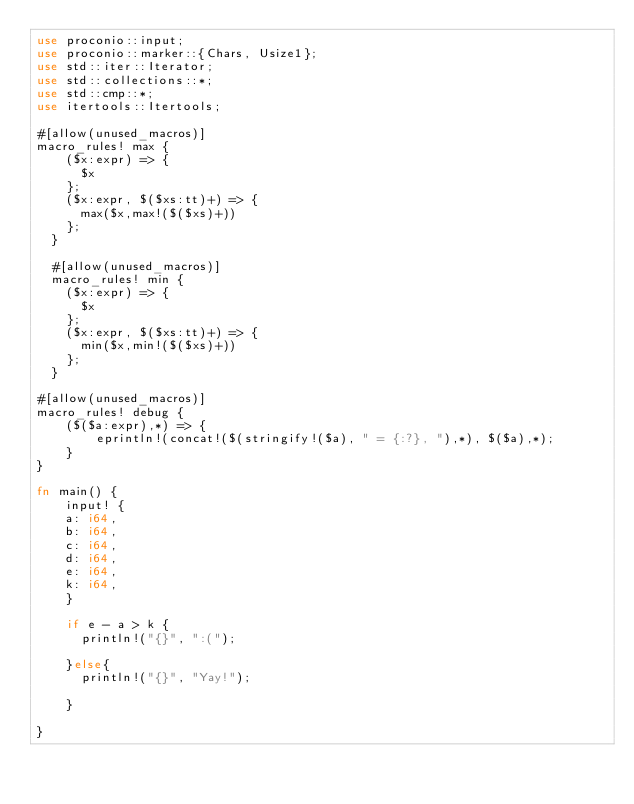<code> <loc_0><loc_0><loc_500><loc_500><_Rust_>use proconio::input;
use proconio::marker::{Chars, Usize1};
use std::iter::Iterator;
use std::collections::*;
use std::cmp::*;
use itertools::Itertools;

#[allow(unused_macros)]
macro_rules! max {
    ($x:expr) => {
      $x
    };
    ($x:expr, $($xs:tt)+) => {
      max($x,max!($($xs)+))
    };
  }
  
  #[allow(unused_macros)]
  macro_rules! min {
    ($x:expr) => {
      $x
    };
    ($x:expr, $($xs:tt)+) => {
      min($x,min!($($xs)+))
    };
  }

#[allow(unused_macros)]
macro_rules! debug {
    ($($a:expr),*) => {
        eprintln!(concat!($(stringify!($a), " = {:?}, "),*), $($a),*);
    }
}

fn main() {
    input! {
    a: i64,
    b: i64,
    c: i64,
    d: i64,
    e: i64,
    k: i64,
    }

    if e - a > k {
      println!("{}", ":(");

    }else{
      println!("{}", "Yay!");

    }

}
</code> 